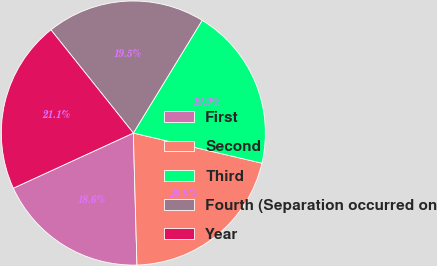<chart> <loc_0><loc_0><loc_500><loc_500><pie_chart><fcel>First<fcel>Second<fcel>Third<fcel>Fourth (Separation occurred on<fcel>Year<nl><fcel>18.58%<fcel>20.9%<fcel>19.94%<fcel>19.45%<fcel>21.13%<nl></chart> 